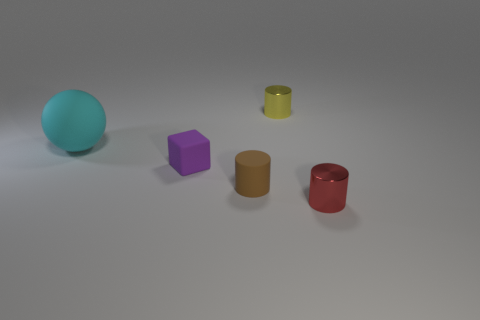Subtract all cyan cylinders. Subtract all gray spheres. How many cylinders are left? 3 Add 4 tiny cubes. How many objects exist? 9 Subtract all spheres. How many objects are left? 4 Subtract all cubes. Subtract all small cyan things. How many objects are left? 4 Add 2 cubes. How many cubes are left? 3 Add 4 small red rubber cylinders. How many small red rubber cylinders exist? 4 Subtract 0 red balls. How many objects are left? 5 